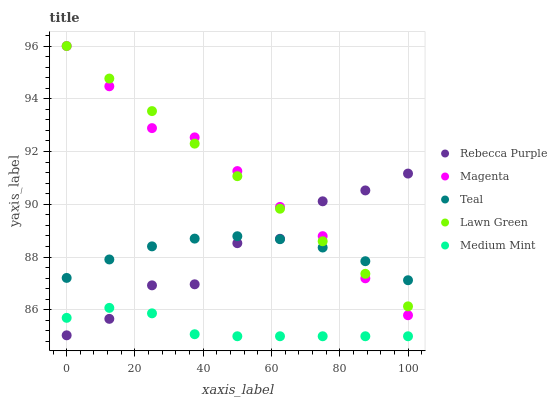Does Medium Mint have the minimum area under the curve?
Answer yes or no. Yes. Does Lawn Green have the maximum area under the curve?
Answer yes or no. Yes. Does Magenta have the minimum area under the curve?
Answer yes or no. No. Does Magenta have the maximum area under the curve?
Answer yes or no. No. Is Lawn Green the smoothest?
Answer yes or no. Yes. Is Rebecca Purple the roughest?
Answer yes or no. Yes. Is Magenta the smoothest?
Answer yes or no. No. Is Magenta the roughest?
Answer yes or no. No. Does Medium Mint have the lowest value?
Answer yes or no. Yes. Does Lawn Green have the lowest value?
Answer yes or no. No. Does Magenta have the highest value?
Answer yes or no. Yes. Does Rebecca Purple have the highest value?
Answer yes or no. No. Is Medium Mint less than Teal?
Answer yes or no. Yes. Is Teal greater than Medium Mint?
Answer yes or no. Yes. Does Rebecca Purple intersect Magenta?
Answer yes or no. Yes. Is Rebecca Purple less than Magenta?
Answer yes or no. No. Is Rebecca Purple greater than Magenta?
Answer yes or no. No. Does Medium Mint intersect Teal?
Answer yes or no. No. 